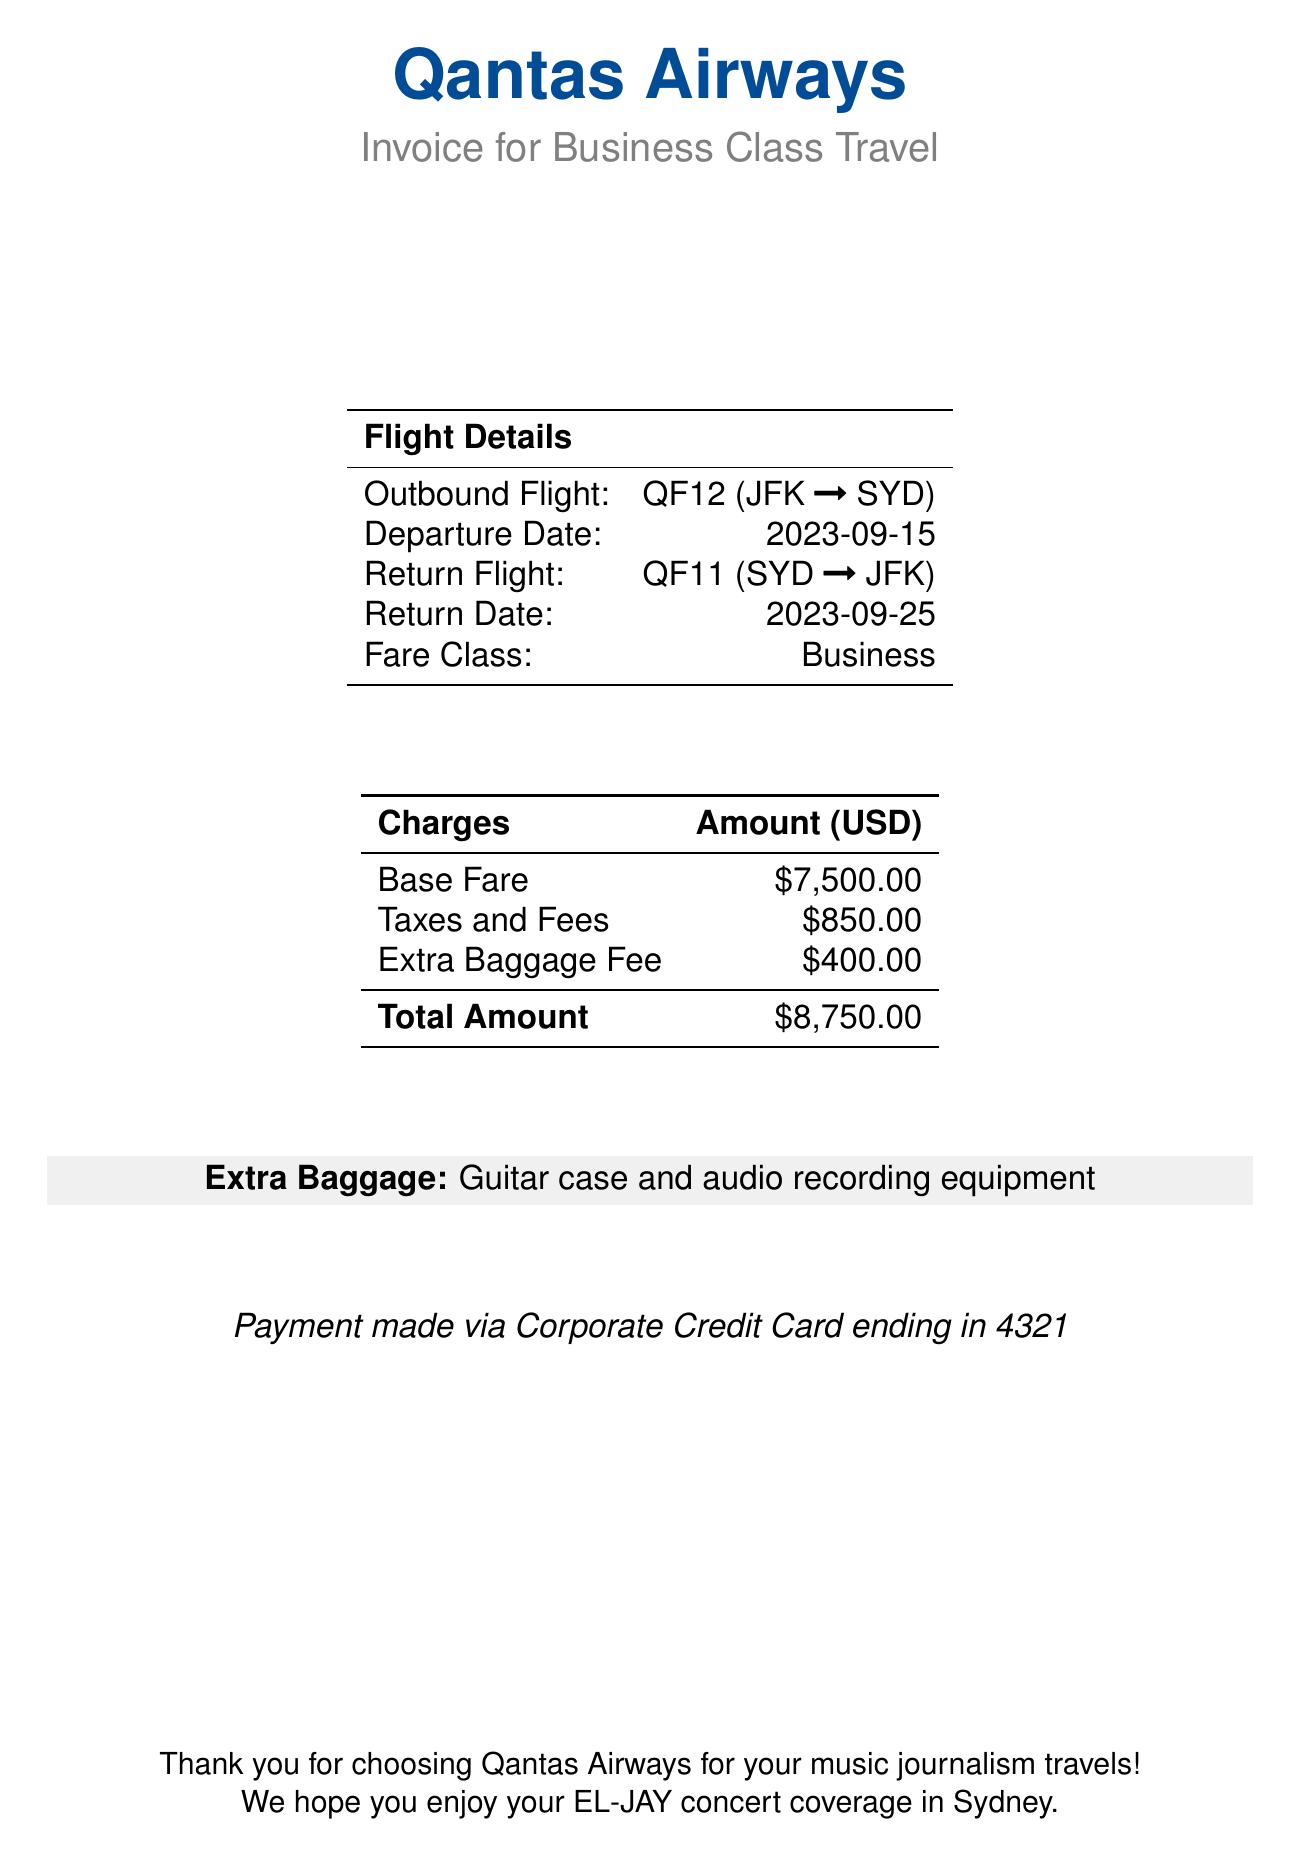What is the passenger's name? The passenger's name is located in the top section of the document.
Answer: Alex Thompson What is the booking reference? The booking reference can be found under the passenger information section.
Answer: QFXYZ123 What is the total amount charged? The total amount charged is listed in the charges table at the bottom of the document.
Answer: $8,750.00 How much is the base fare? The base fare is specified in the charges section of the invoice.
Answer: $7,500.00 What is the departure date? The departure date is provided in the flight details section.
Answer: 2023-09-15 What equipment is included in the extra baggage? The extra baggage information mentions specific items included with the fee.
Answer: Guitar case and audio recording equipment What airline is the invoice from? The airline's name is prominently displayed at the top of the document.
Answer: Qantas Airways What class of fare is the ticket? The fare class is mentioned in the flight details section of the document.
Answer: Business What method of payment was used? The payment method is indicated at the bottom of the document.
Answer: Corporate Credit Card ending in 4321 